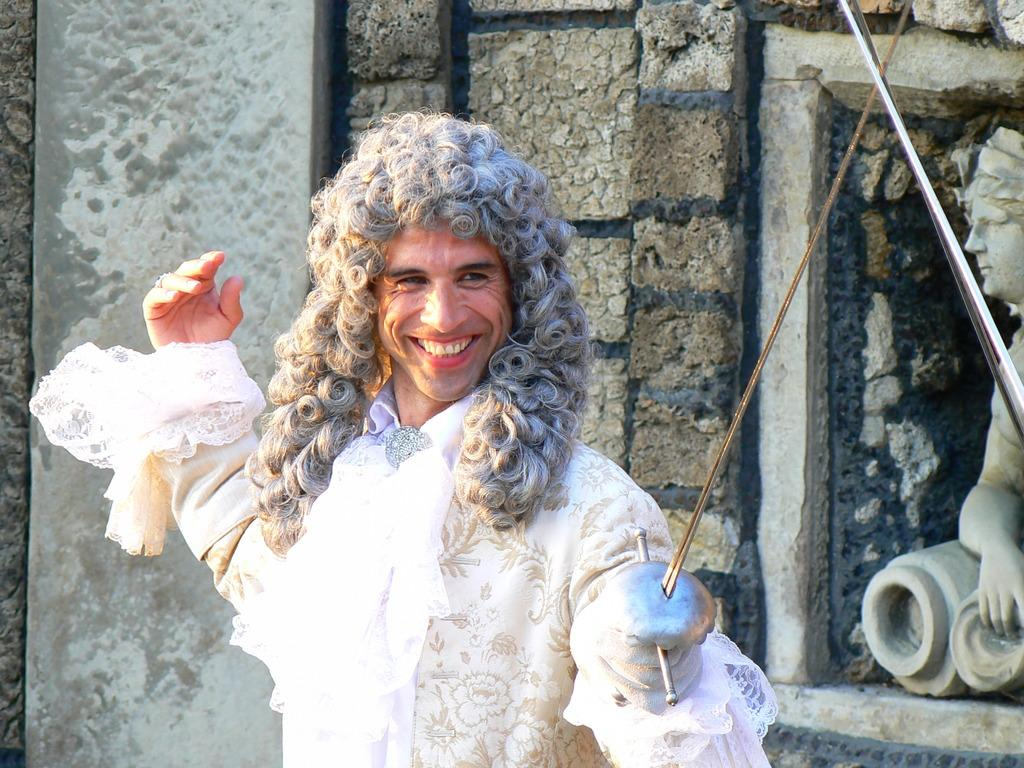Who is present in the image? There is a man in the image. What is the man doing in the image? The man is smiling in the image. What is the man wearing in the image? The man is wearing a white dress in the image. What can be seen on the wall in the image? There is a statue on the wall in the image. What type of nut is the man holding in the image? There is no nut present in the image; the man is not holding anything. 